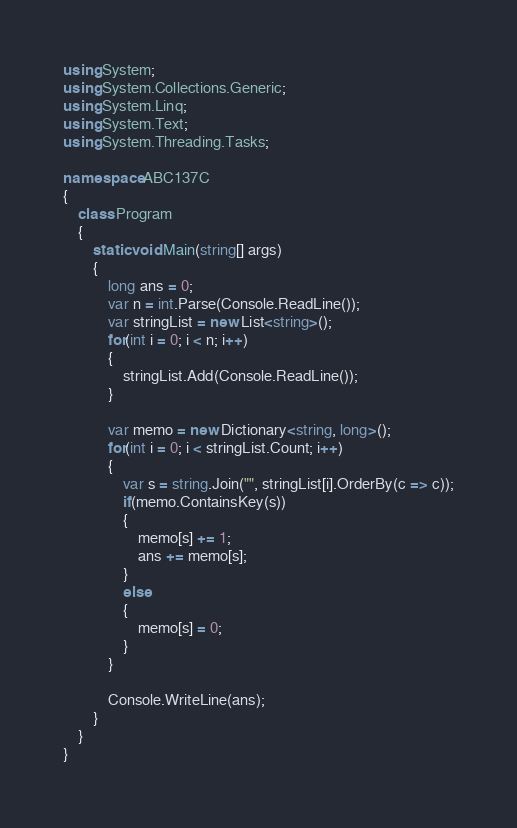<code> <loc_0><loc_0><loc_500><loc_500><_C#_>using System;
using System.Collections.Generic;
using System.Linq;
using System.Text;
using System.Threading.Tasks;

namespace ABC137C
{
    class Program
    {
        static void Main(string[] args)
        {
            long ans = 0;
            var n = int.Parse(Console.ReadLine());
            var stringList = new List<string>();
            for(int i = 0; i < n; i++)
            {
                stringList.Add(Console.ReadLine());
            }

            var memo = new Dictionary<string, long>();
            for(int i = 0; i < stringList.Count; i++)
            {
                var s = string.Join("", stringList[i].OrderBy(c => c));
                if(memo.ContainsKey(s))
                {
                    memo[s] += 1;
                    ans += memo[s];
                }
                else
                {
                    memo[s] = 0;
                }
            }

            Console.WriteLine(ans);
        }
    }
}
</code> 